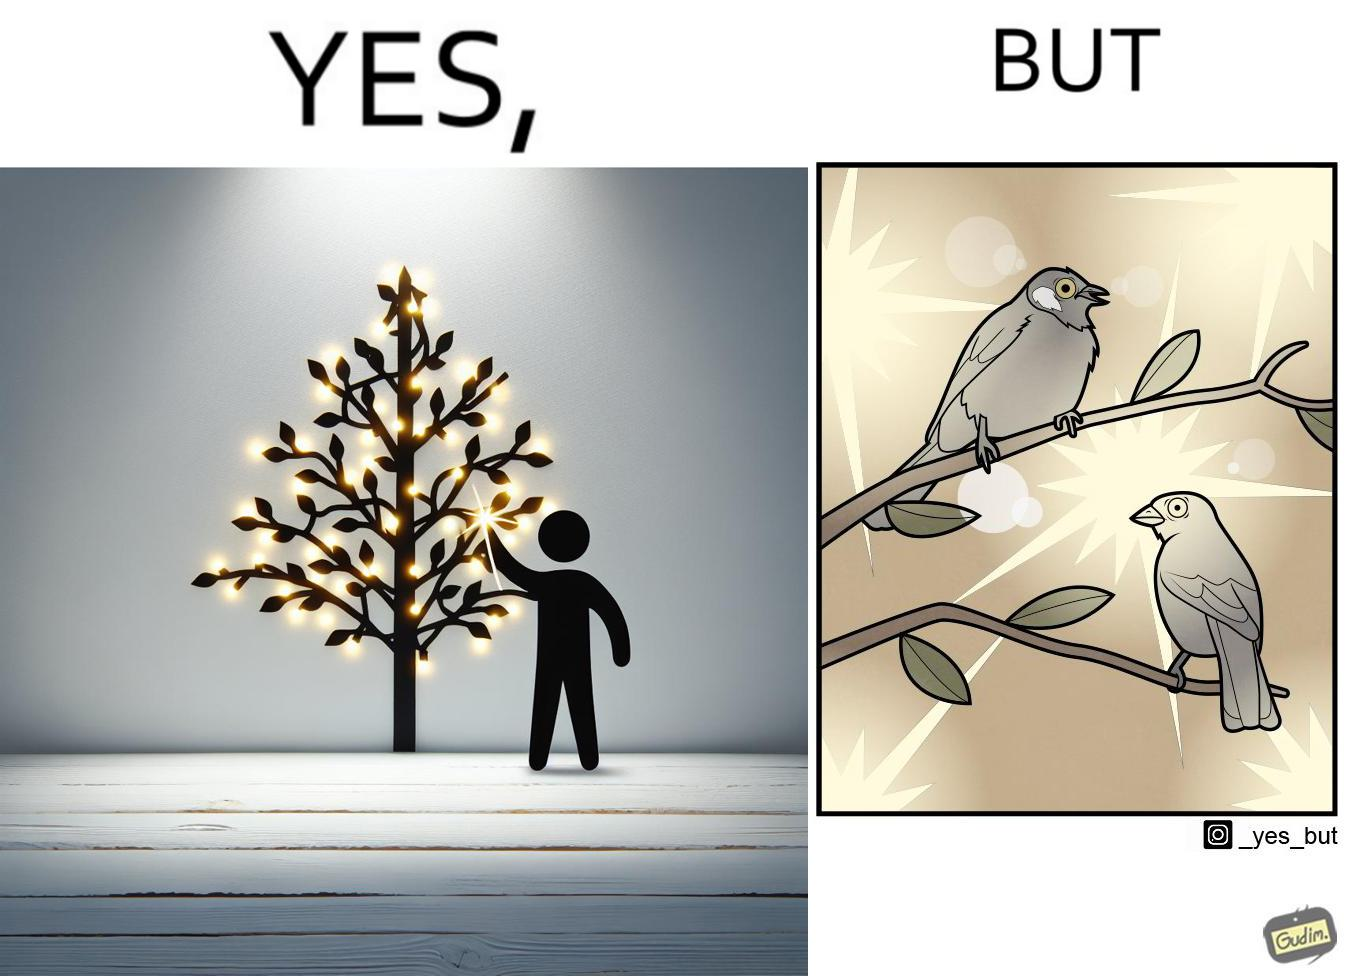Explain the humor or irony in this image. The images are ironic since they show how putting a lot of lights as decorations on trees make them beautiful to look at for us but cause trouble to the birds who actually live on trees for no good reason 